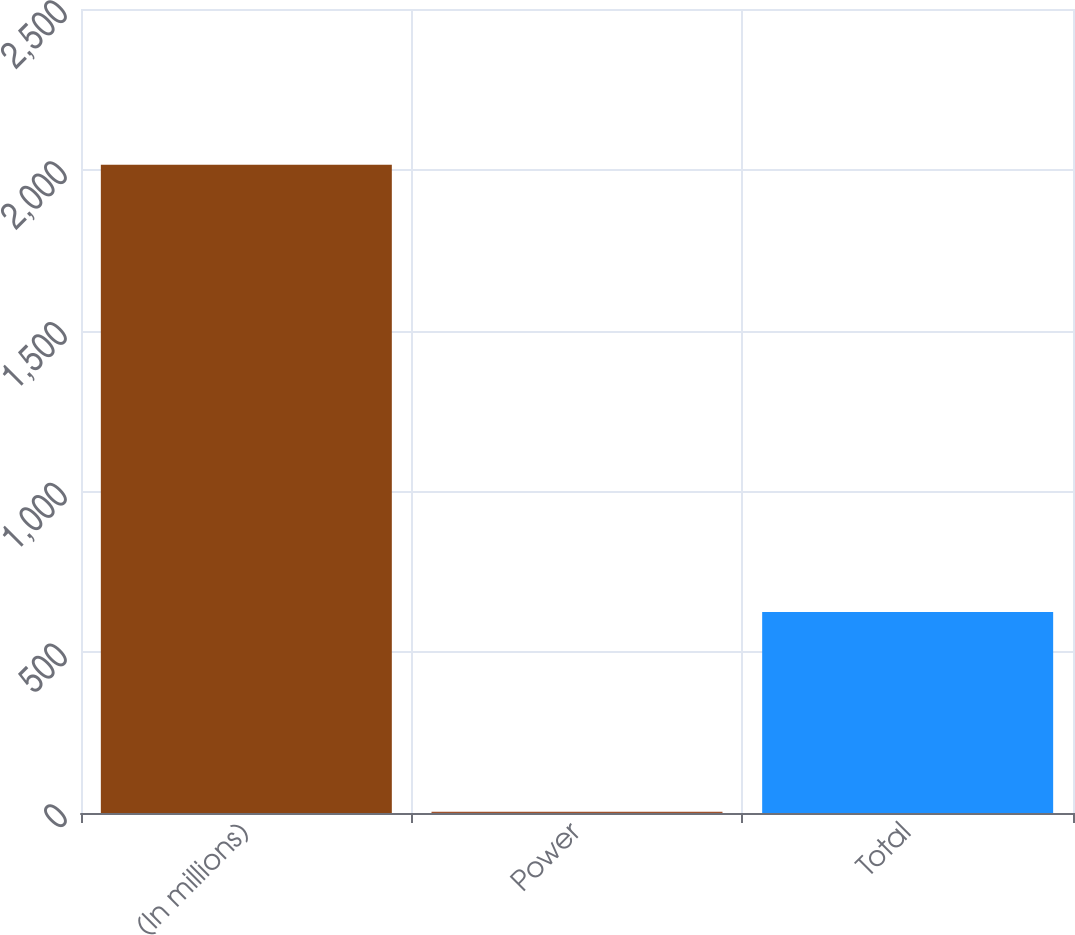Convert chart. <chart><loc_0><loc_0><loc_500><loc_500><bar_chart><fcel>(In millions)<fcel>Power<fcel>Total<nl><fcel>2016<fcel>4<fcel>625<nl></chart> 